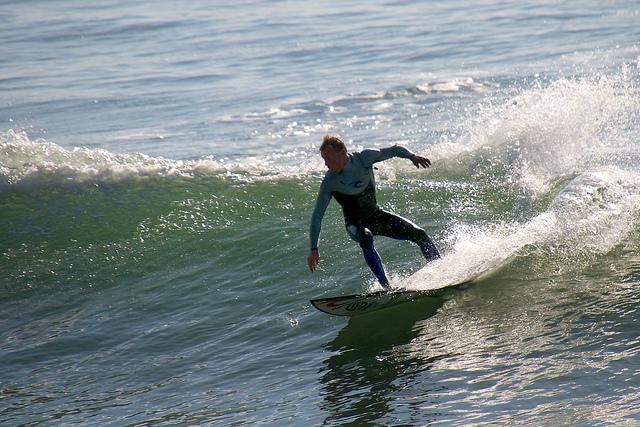What color is the surfer's wetsuit?
Quick response, please. Black. Is the surfer upright on the board?
Quick response, please. Yes. Is he wearing a wetsuit?
Be succinct. Yes. Is his head covered?
Answer briefly. No. What is under the person's feet?
Write a very short answer. Surfboard. What is the man doing?
Give a very brief answer. Surfing. Is the wave big?
Short answer required. No. Can you see both of the man's arms?
Concise answer only. Yes. 